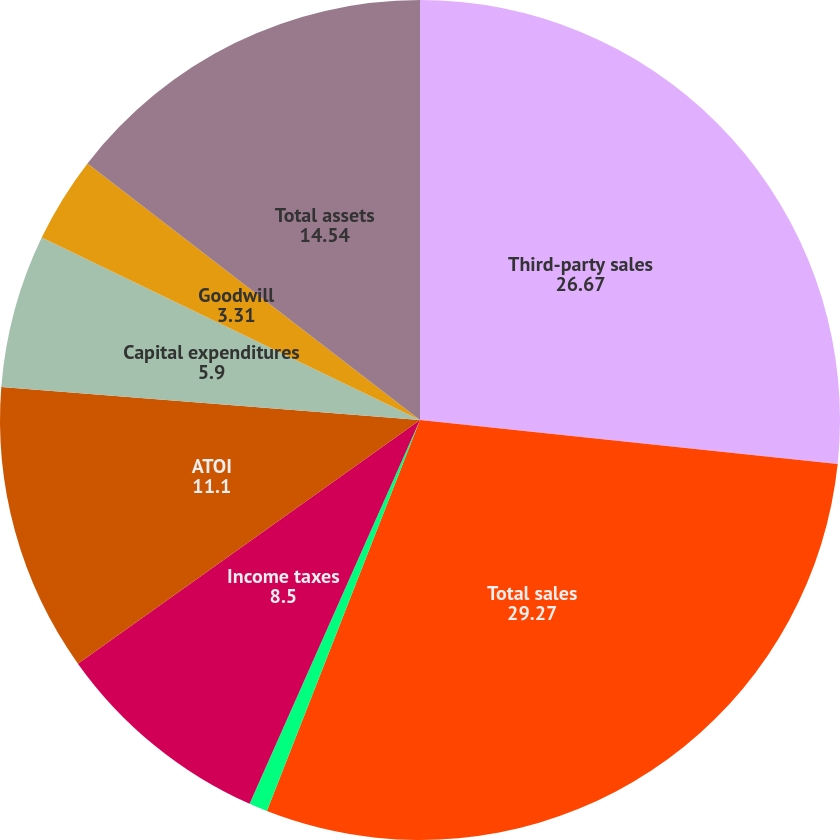Convert chart to OTSL. <chart><loc_0><loc_0><loc_500><loc_500><pie_chart><fcel>Third-party sales<fcel>Total sales<fcel>Depreciation and amortization<fcel>Income taxes<fcel>ATOI<fcel>Capital expenditures<fcel>Goodwill<fcel>Total assets<nl><fcel>26.67%<fcel>29.27%<fcel>0.71%<fcel>8.5%<fcel>11.1%<fcel>5.9%<fcel>3.31%<fcel>14.54%<nl></chart> 